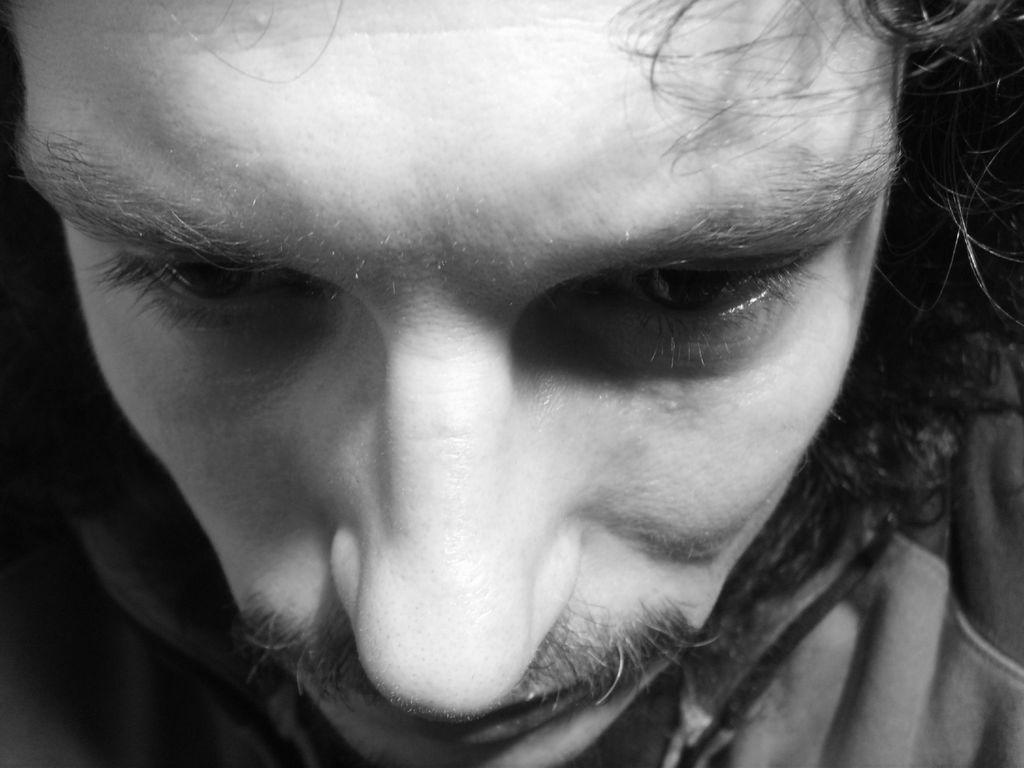What is the main subject of the image? There is a person's face in the image. What color scheme is used in the image? The image is in black and white. What type of thread is being used to stitch the person's mind in the image? There is no thread or stitching present in the image, as it features a person's face in black and white. 